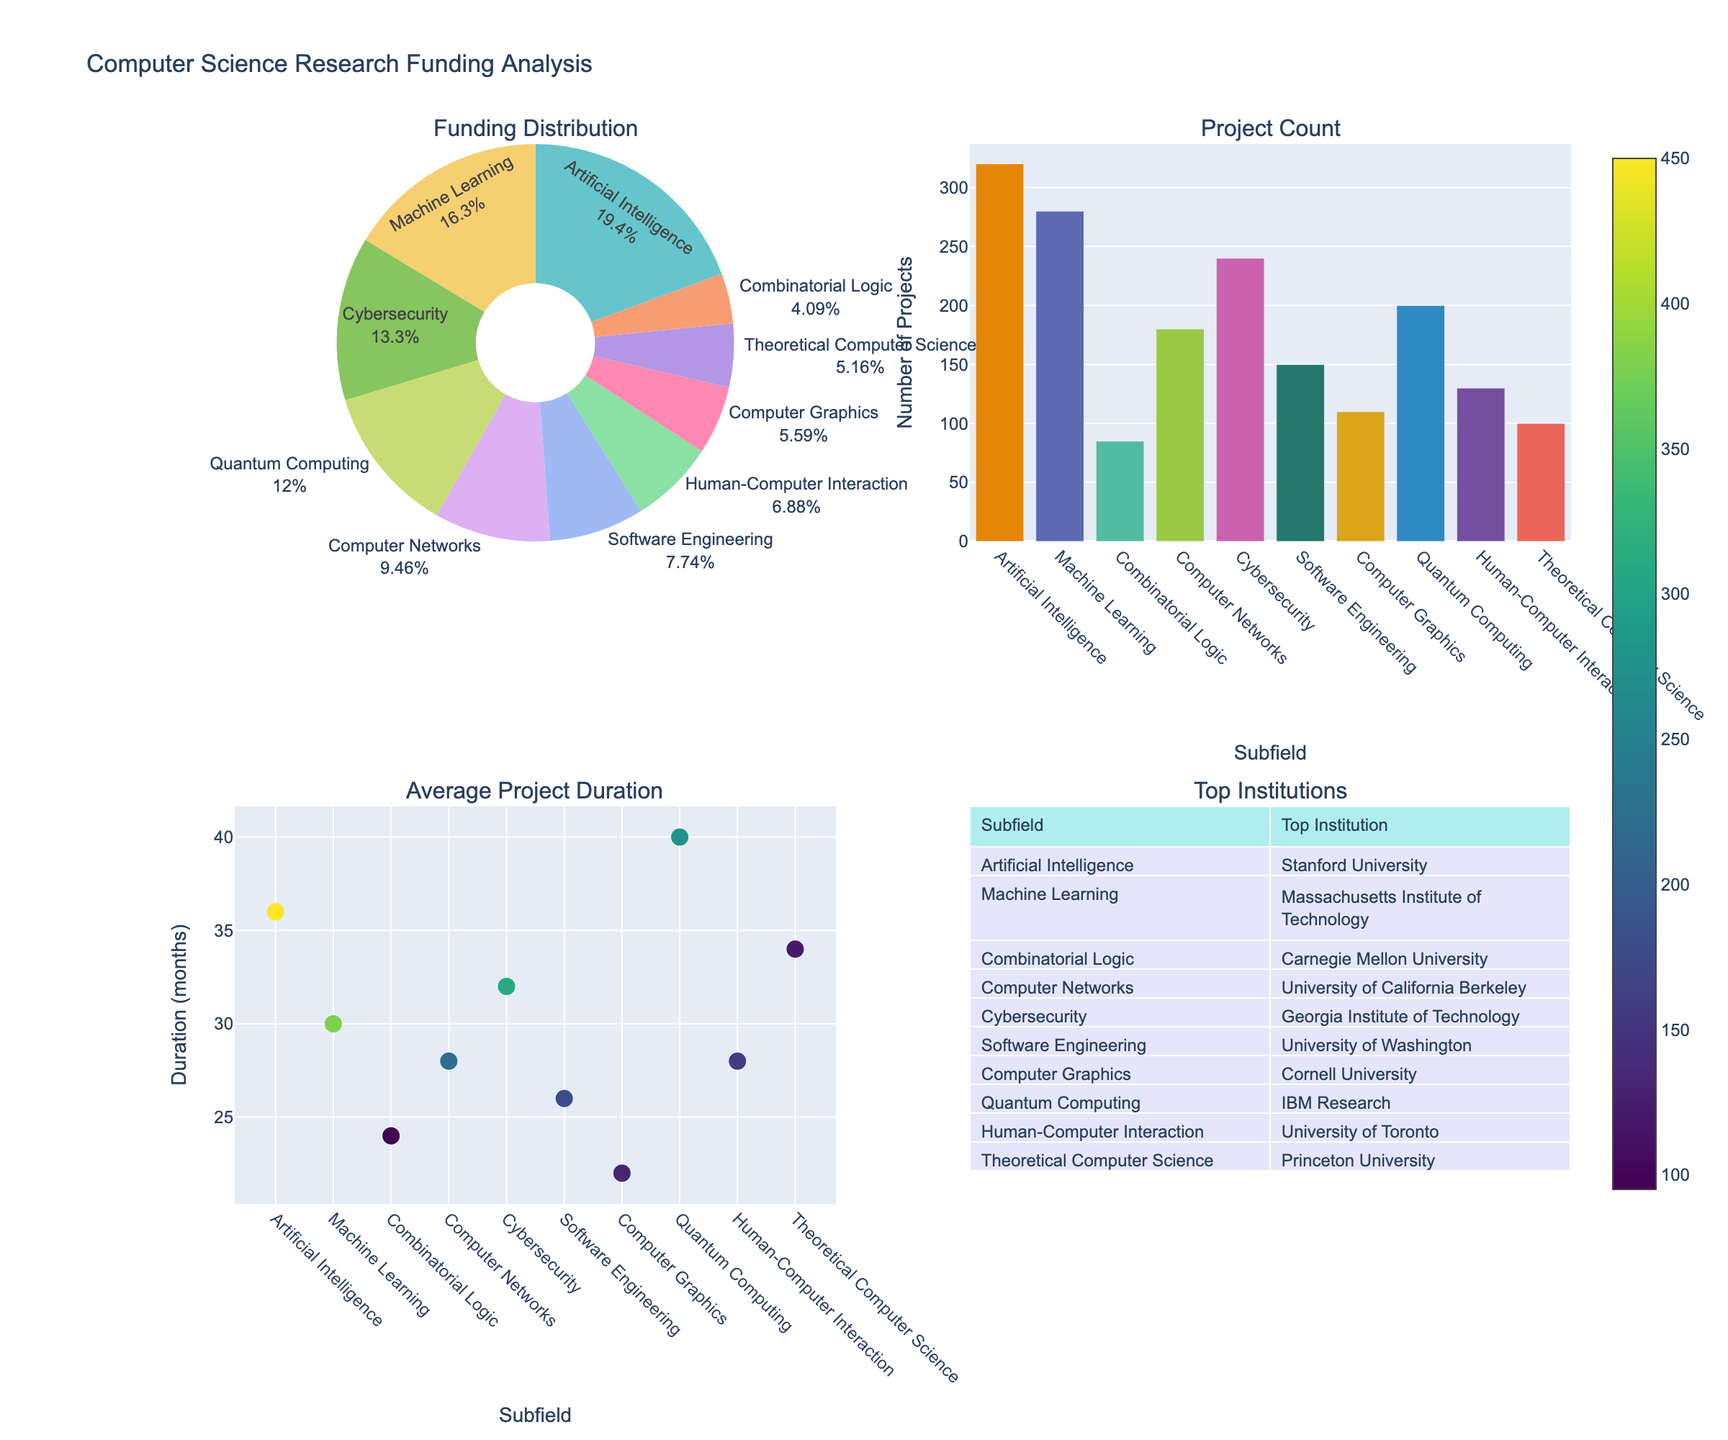How is the research funding distributed among different computer science subfields? Analyze the pie chart in the "Funding Distribution" subplot. It shows each subfield's share of the total research funding. The percentages for each subfield give a clear view of the distribution.
Answer: Distributed among various subfields, with AI having the largest share Which computer science subfield has the highest number of projects? Refer to the bar chart in the "Project Count" subplot. The subfield with the tallest bar represents the highest number of projects.
Answer: Artificial Intelligence What is the average project duration for research in Quantum Computing? Check the scatter plot in the "Average Project Duration" subplot. Look for the data point corresponding to Quantum Computing and read its y-axis value.
Answer: 40 months Which institution is identified as the top for Human-Computer Interaction research? Consult the table in the "Top Institutions" subplot. Find the row for Human-Computer Interaction to see the corresponding top institution.
Answer: University of Toronto What is the total funding for Combinatorial Logic and Cybersecurity combined? Sum the funding values for both subfields: 95 + 310.
Answer: 405 USD millions How does the average project duration in Theoretical Computer Science compare with Artificial Intelligence? Compare the y-axis values for both subfields in the scatter plot. Theoretical Computer Science has a value of 34, and Artificial Intelligence has a value of 36.
Answer: Theoretical Computer Science is 2 months shorter Which subfield has a higher number of projects: Machine Learning or Cybersecurity? Observe the bar chart in the "Project Count" subplot. Compare the height of the bars for Machine Learning and Cybersecurity.
Answer: Machine Learning What proportion of the total funding does Computer Graphics receive? Refer to the pie chart in the "Funding Distribution" subplot. The text should indicate the percentage allocated to Computer Graphics.
Answer: 6.5% How do the number of projects in Software Engineering compare to those in Quantum Computing? Use the bar chart in the "Project Count" subplot to compare the heights for Software Engineering and Quantum Computing.
Answer: Software Engineering has fewer projects What is the average project duration across all subfields? Average the y-axis values from the scatter plot for all subfields: (36 + 30 + 24 + 28 + 32 + 26 + 22 + 40 + 28 + 34) / 10.
Answer: 30 months 